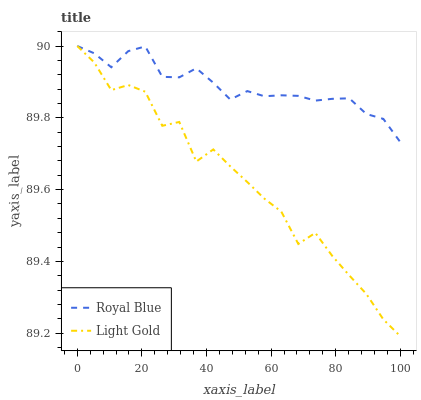Does Light Gold have the minimum area under the curve?
Answer yes or no. Yes. Does Royal Blue have the maximum area under the curve?
Answer yes or no. Yes. Does Light Gold have the maximum area under the curve?
Answer yes or no. No. Is Royal Blue the smoothest?
Answer yes or no. Yes. Is Light Gold the roughest?
Answer yes or no. Yes. Is Light Gold the smoothest?
Answer yes or no. No. Does Light Gold have the lowest value?
Answer yes or no. Yes. Does Light Gold have the highest value?
Answer yes or no. Yes. Does Light Gold intersect Royal Blue?
Answer yes or no. Yes. Is Light Gold less than Royal Blue?
Answer yes or no. No. Is Light Gold greater than Royal Blue?
Answer yes or no. No. 